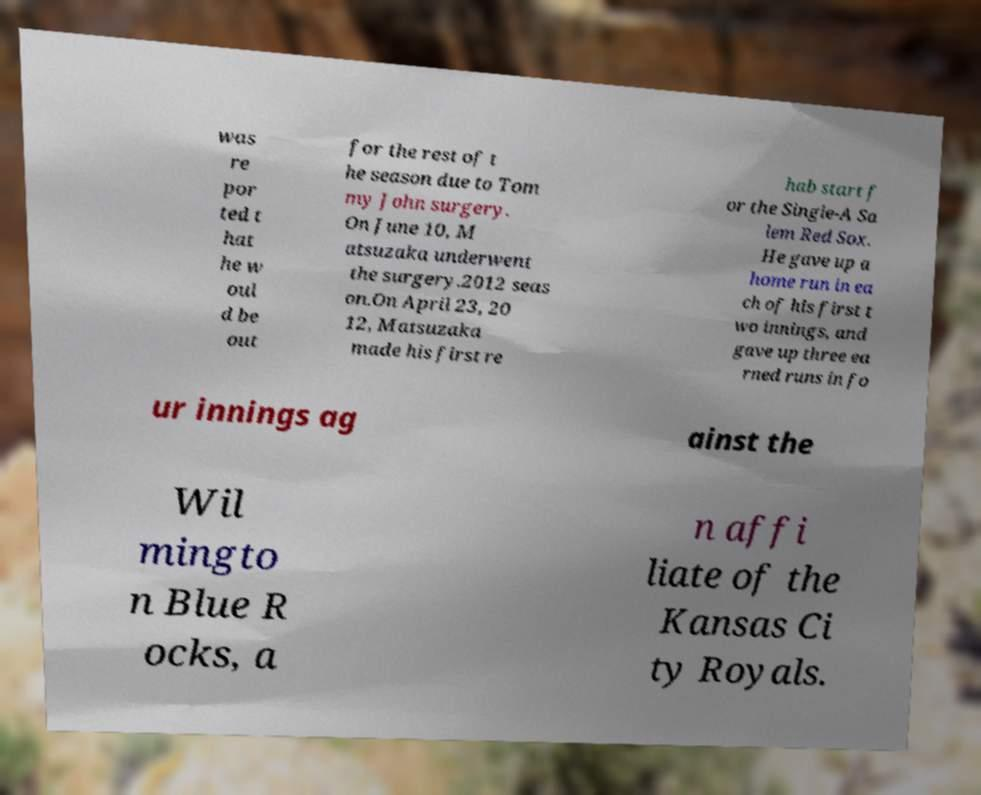I need the written content from this picture converted into text. Can you do that? was re por ted t hat he w oul d be out for the rest of t he season due to Tom my John surgery. On June 10, M atsuzaka underwent the surgery.2012 seas on.On April 23, 20 12, Matsuzaka made his first re hab start f or the Single-A Sa lem Red Sox. He gave up a home run in ea ch of his first t wo innings, and gave up three ea rned runs in fo ur innings ag ainst the Wil mingto n Blue R ocks, a n affi liate of the Kansas Ci ty Royals. 